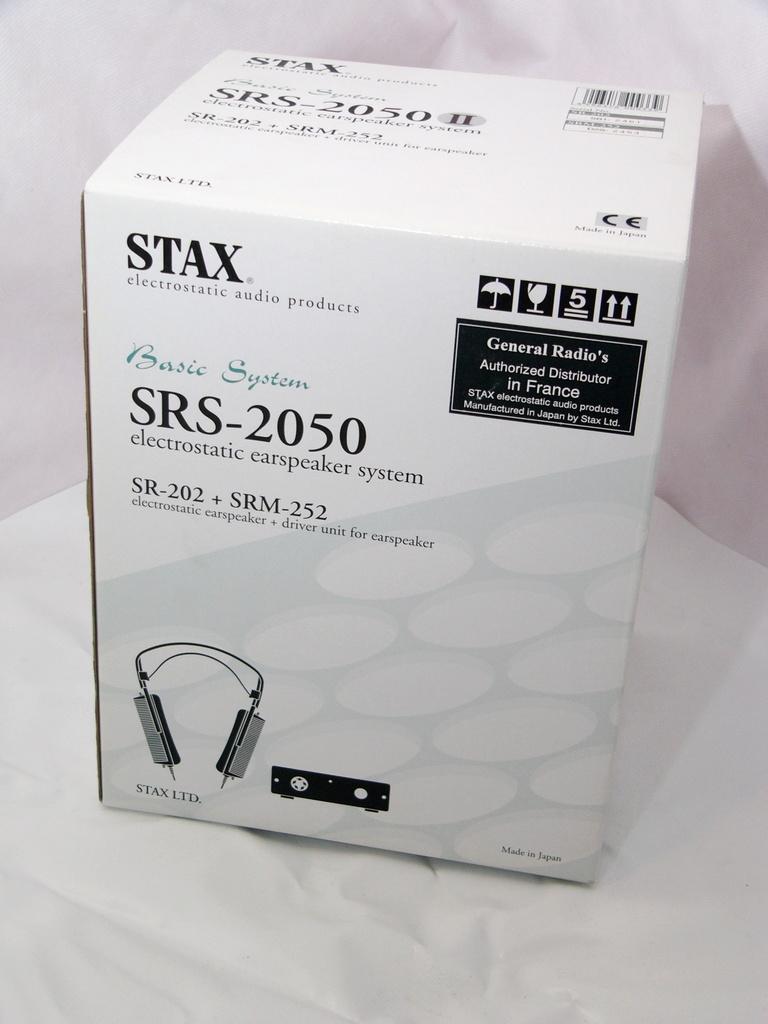What brand is this product?
Your answer should be compact. Stax. What type of product is this?
Your answer should be compact. Electrostatic earspeaker system. 